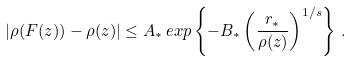Convert formula to latex. <formula><loc_0><loc_0><loc_500><loc_500>\left | \rho ( F ( z ) ) - \rho ( z ) \right | \leq A _ { * } \, e x p \left \{ - B _ { * } \left ( \frac { r _ { * } } { \rho ( z ) } \right ) ^ { 1 / s } \right \} \, .</formula> 